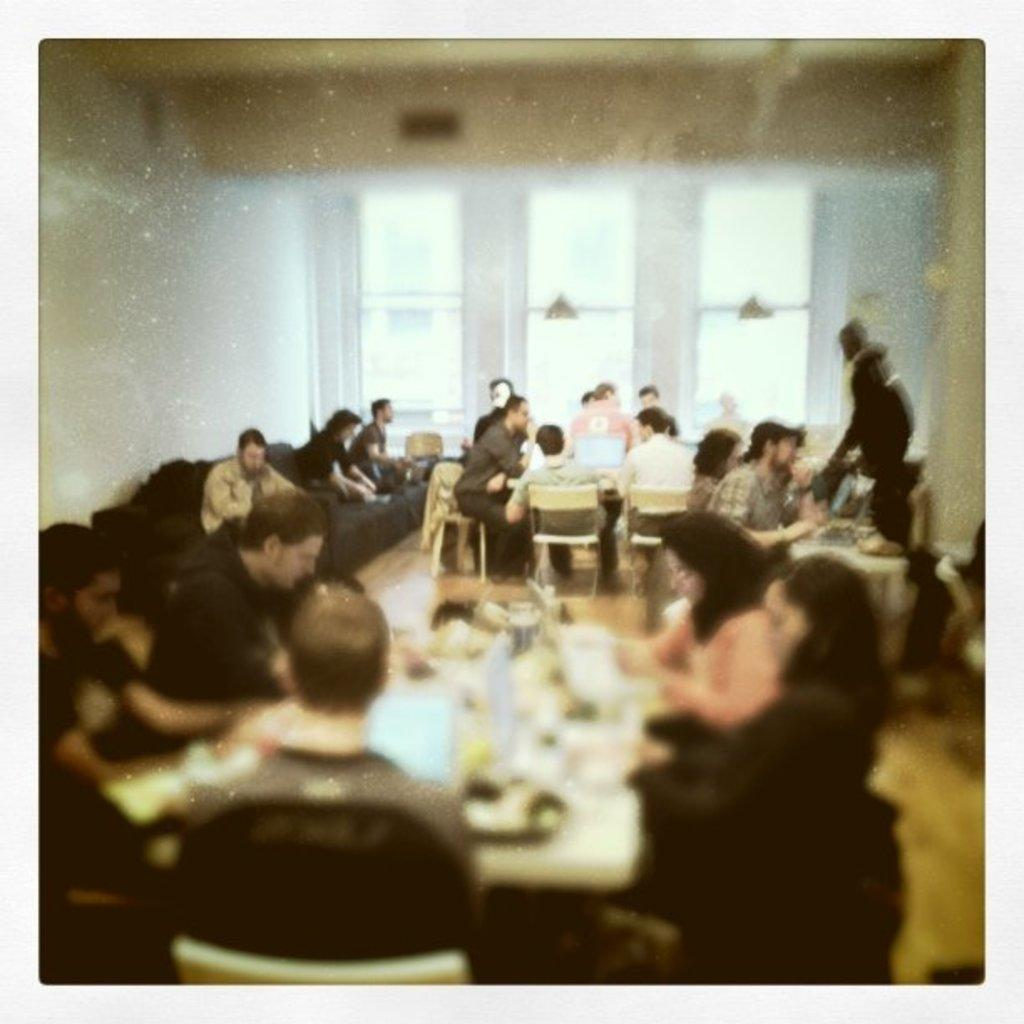How many people are in the image? There is a group of people in the image. What are some of the people doing in the image? Some people are seated on chairs, while others are standing. What is the purpose of the table in the image? There is a table in the image, and food items are present on it. Can you tell me how many trees are visible in the image? There are no trees visible in the image; it appears to be an indoor setting with a group of people, chairs, a table, and food items. Is there a goat present in the image? No, there is no goat present in the image. 